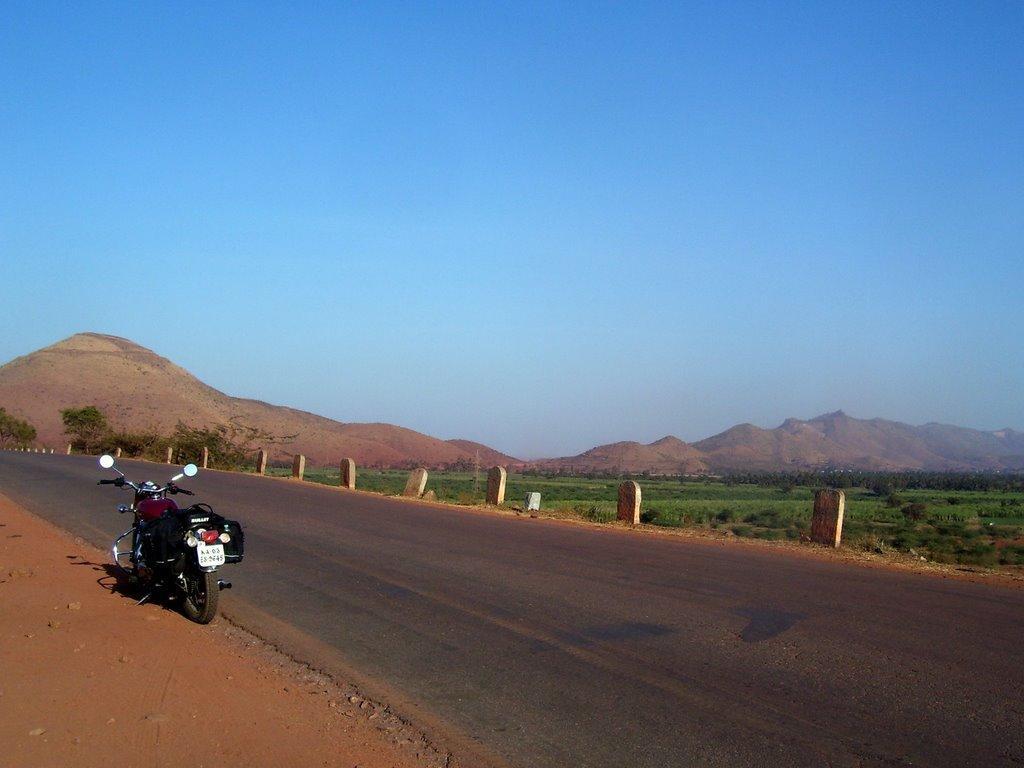Please provide a concise description of this image. In this image we can see a motorbike parked on the side of the road. Here we can see the milestones, farmland, trees, hills and the blue sky in the background. 